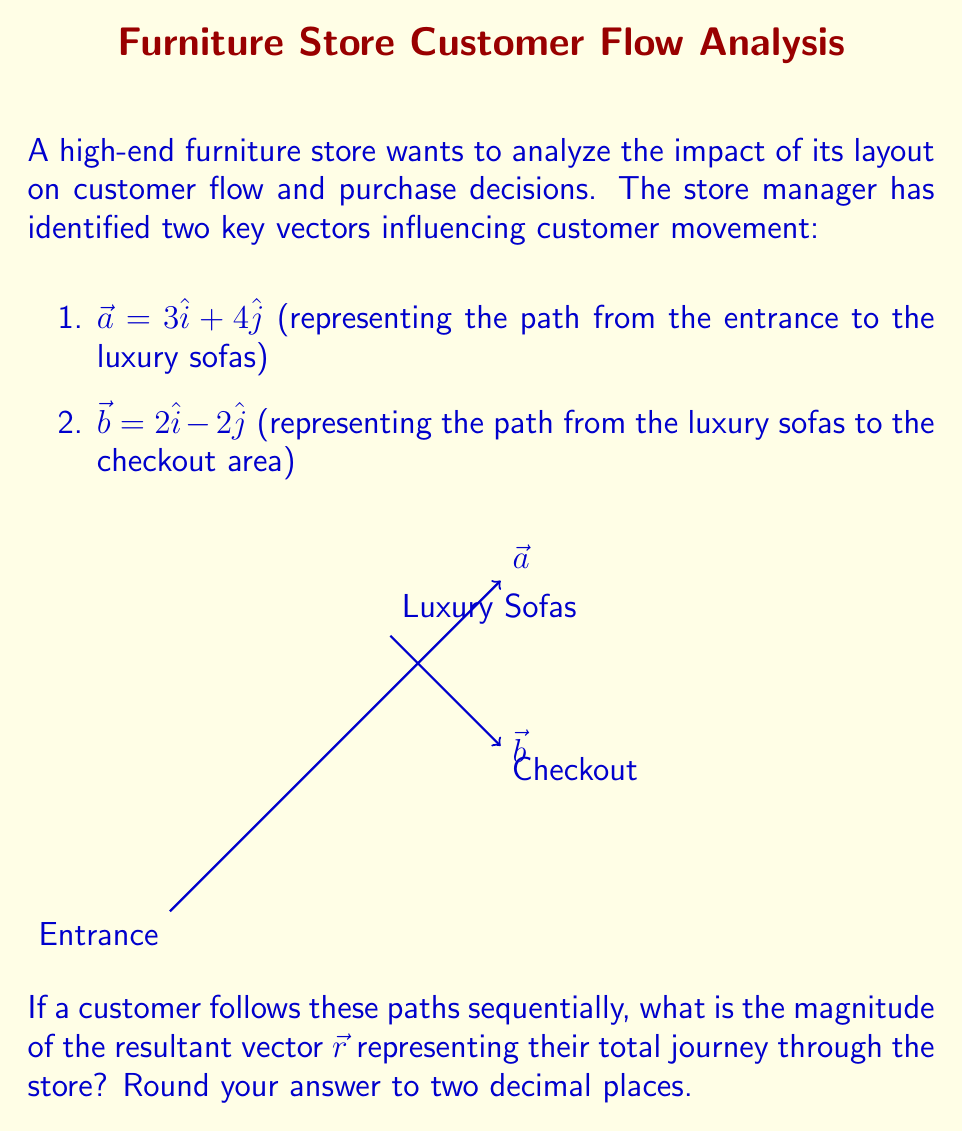Show me your answer to this math problem. To solve this problem, we need to follow these steps:

1) First, we need to find the resultant vector $\vec{r}$ by adding the two given vectors:

   $\vec{r} = \vec{a} + \vec{b}$

2) Let's add the vectors component-wise:

   $\vec{r} = (3\hat{i} + 4\hat{j}) + (2\hat{i} - 2\hat{j})$
   $\vec{r} = (3+2)\hat{i} + (4-2)\hat{j}$
   $\vec{r} = 5\hat{i} + 2\hat{j}$

3) Now that we have the resultant vector, we need to find its magnitude. The magnitude of a vector $\vec{v} = x\hat{i} + y\hat{j}$ is given by the formula:

   $|\vec{v}| = \sqrt{x^2 + y^2}$

4) Let's apply this formula to our resultant vector:

   $|\vec{r}| = \sqrt{5^2 + 2^2}$

5) Simplify:

   $|\vec{r}| = \sqrt{25 + 4} = \sqrt{29}$

6) Calculate and round to two decimal places:

   $|\vec{r}| \approx 5.39$

Therefore, the magnitude of the resultant vector representing the customer's total journey through the store is approximately 5.39 units.
Answer: 5.39 units 